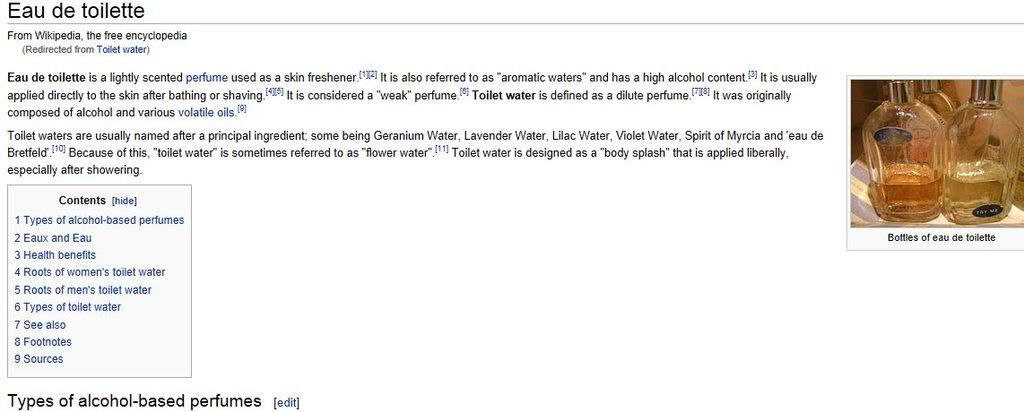<image>
Present a compact description of the photo's key features. Wikipedia article for Eau de toilette showing a picture of two bottles. 